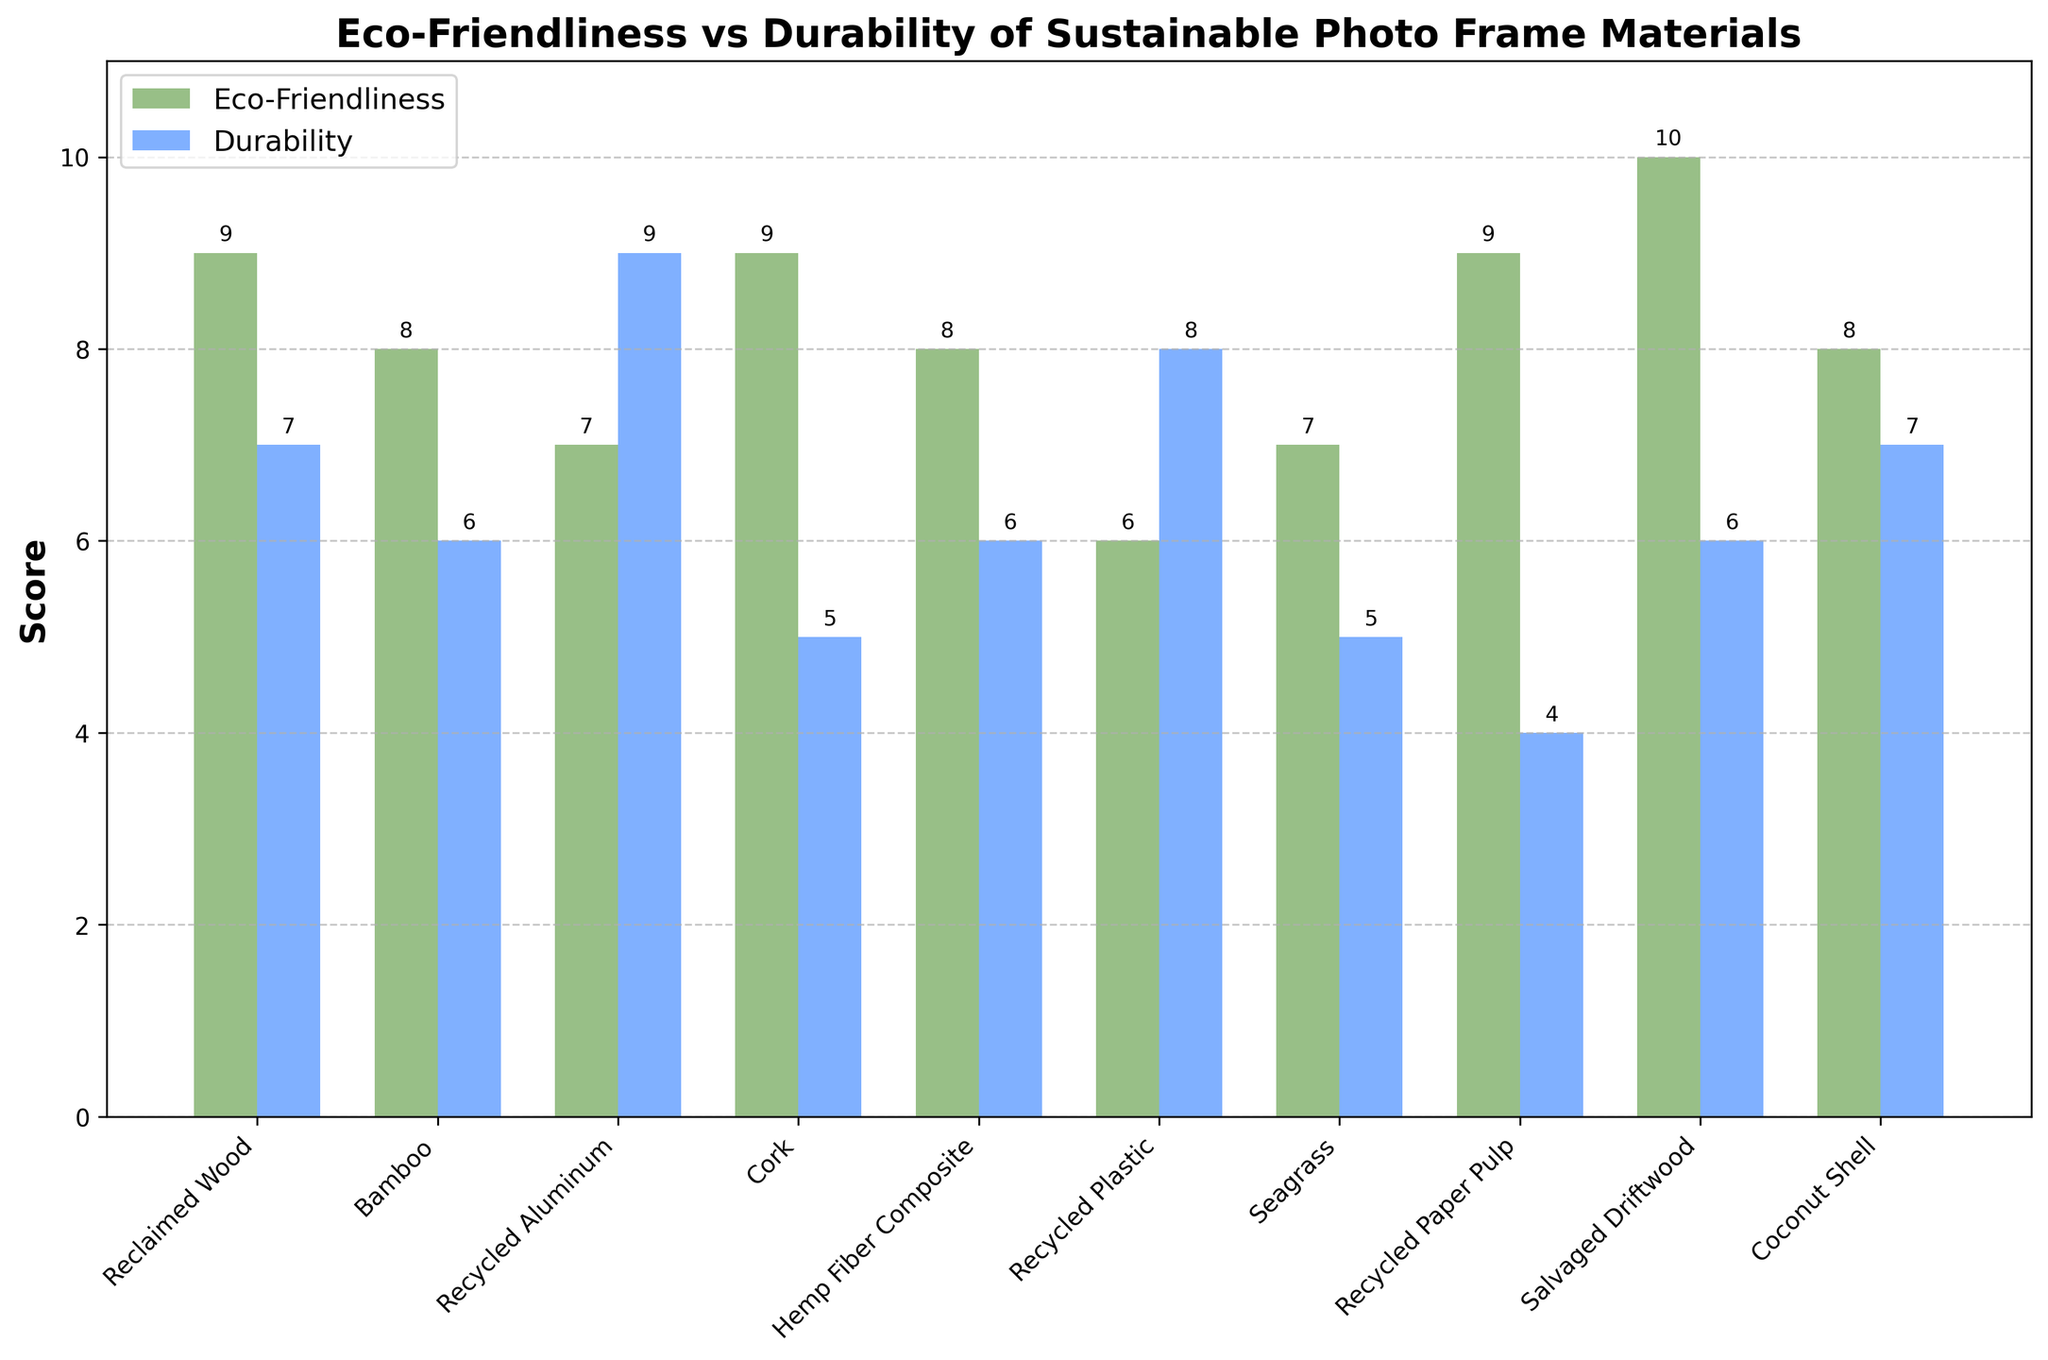What material has the highest eco-friendliness score? The material with the tallest green bar is Salvaged Driftwood, indicating the highest eco-friendliness score.
Answer: Salvaged Driftwood Which material shows the greatest difference between eco-friendliness and durability scores? By observing the difference in bar heights for each material, Recycled Paper Pulp has a significant difference between its high eco-friendliness score (9) and low durability score (4).
Answer: Recycled Paper Pulp Which two materials have the same durability score? The blue bars with the same height indicate equal durability. Bamboo and Hemp Fiber Composite both have a durability score of 6.
Answer: Bamboo and Hemp Fiber Composite What is the average eco-friendliness score of all materials? Sum the eco-friendliness scores and divide by the number of materials: (9 + 8 + 7 + 9 + 8 + 6 + 7 + 9 + 10 + 8) / 10 = 81 / 10 = 8.1.
Answer: 8.1 Which material has the best combination of high eco-friendliness and durability scores? Looking for the material with the tall green and blue bars, Reclaimed Wood stands out with eco-friendliness (9) and durability (7).
Answer: Reclaimed Wood Are there any materials with an eco-friendliness score of 9? If so, which ones? Identify the materials with green bars reaching the 9 mark. Reclaimed Wood, Cork, Recycled Paper Pulp, and Salvaged Driftwood all have a score of 9.
Answer: Reclaimed Wood, Cork, Recycled Paper Pulp, Salvaged Driftwood How does the durability score of Recycled Aluminum compare to Recycled Plastic? Compare the blue bars. Recycled Aluminum has a durability score of 9, while Recycled Plastic has a score of 8.
Answer: Recycled Aluminum is higher What is the total eco-friendliness score for materials with a durability score above 6? Sum eco-friendliness scores for materials with durability > 6: Reclaimed Wood (9), Recycled Aluminum (7), Recycled Plastic (6), Coconut Shell (8). Total is 9 + 7 + 6 + 8 = 30.
Answer: 30 Which material has the lowest durability score, and what is it? The shortest blue bar indicates the lowest durability. Recycled Paper Pulp has the lowest durability score of 4.
Answer: Recycled Paper Pulp, 4 